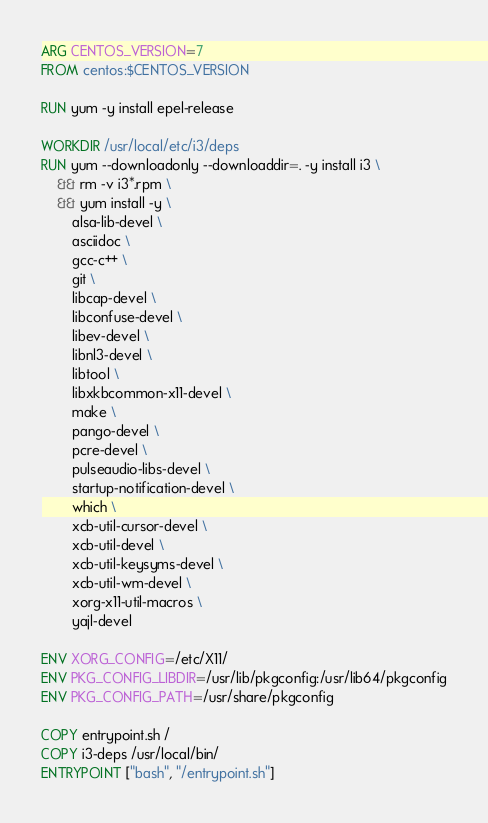Convert code to text. <code><loc_0><loc_0><loc_500><loc_500><_Dockerfile_>ARG CENTOS_VERSION=7
FROM centos:$CENTOS_VERSION

RUN yum -y install epel-release

WORKDIR /usr/local/etc/i3/deps
RUN yum --downloadonly --downloaddir=. -y install i3 \
    && rm -v i3*.rpm \
    && yum install -y \
        alsa-lib-devel \
        asciidoc \
        gcc-c++ \
        git \
        libcap-devel \
        libconfuse-devel \
        libev-devel \
        libnl3-devel \
        libtool \
        libxkbcommon-x11-devel \
        make \
        pango-devel \
        pcre-devel \
        pulseaudio-libs-devel \
        startup-notification-devel \
        which \
        xcb-util-cursor-devel \
        xcb-util-devel \
        xcb-util-keysyms-devel \
        xcb-util-wm-devel \
        xorg-x11-util-macros \
        yajl-devel

ENV XORG_CONFIG=/etc/X11/
ENV PKG_CONFIG_LIBDIR=/usr/lib/pkgconfig:/usr/lib64/pkgconfig
ENV PKG_CONFIG_PATH=/usr/share/pkgconfig

COPY entrypoint.sh /
COPY i3-deps /usr/local/bin/
ENTRYPOINT ["bash", "/entrypoint.sh"]
</code> 